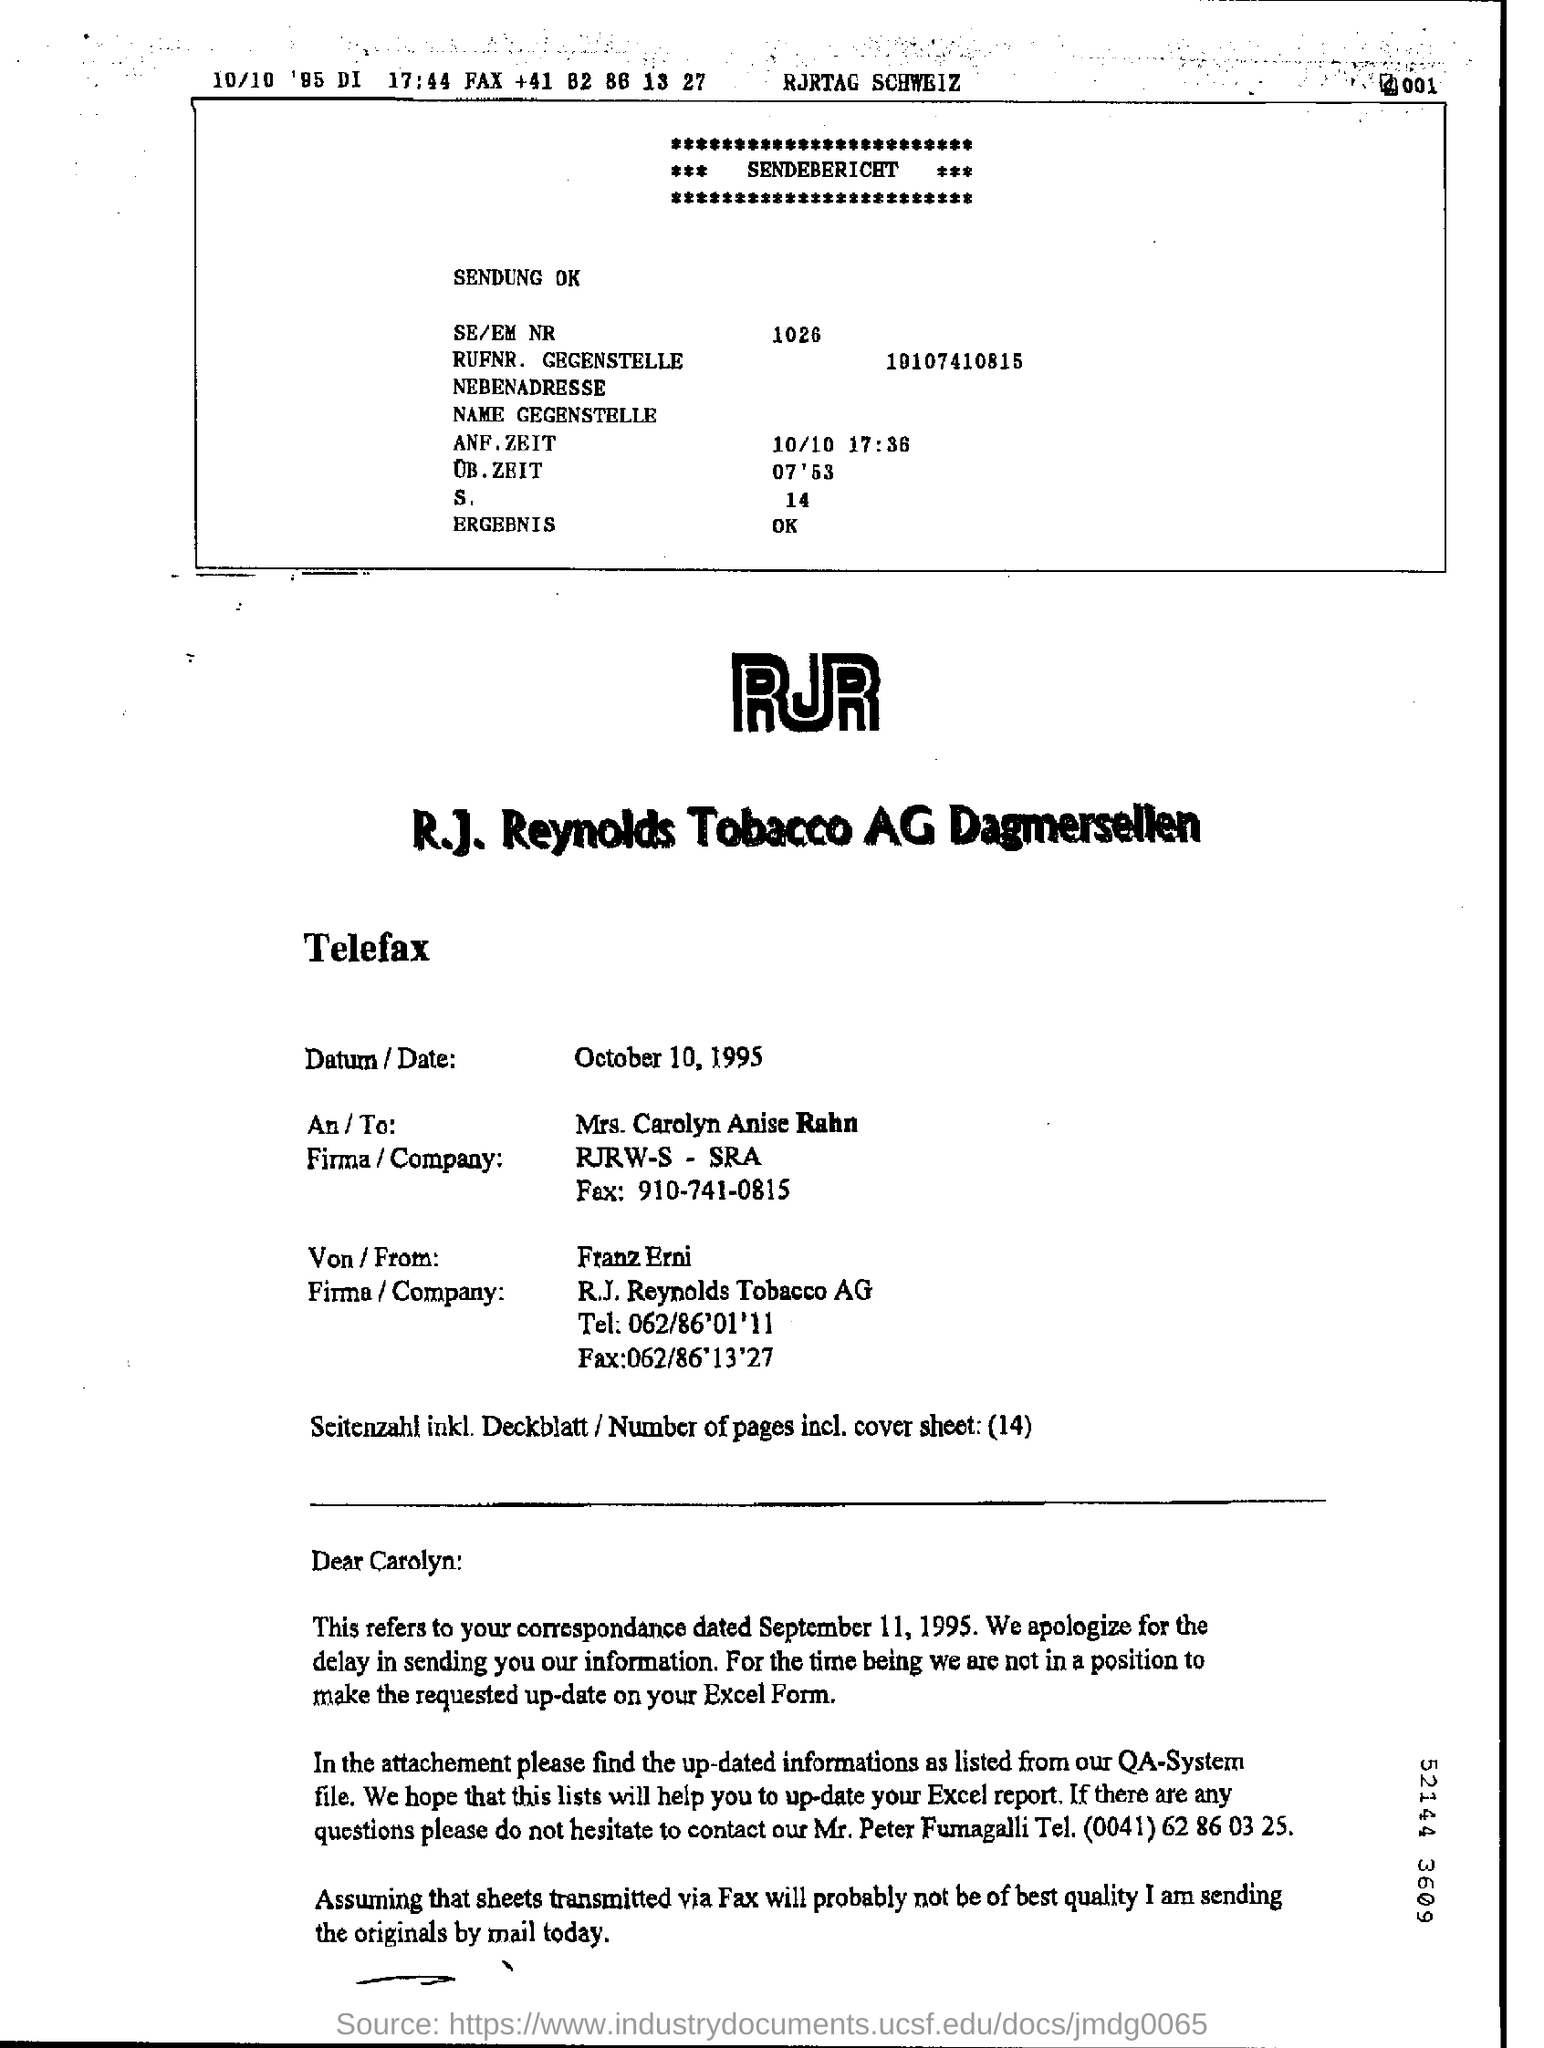Draw attention to some important aspects in this diagram. The company name of Mrs. Carolyn Anise Rahn is RJRW-S -SRA. On October 10, 1995, the date was recorded in a telefax. 